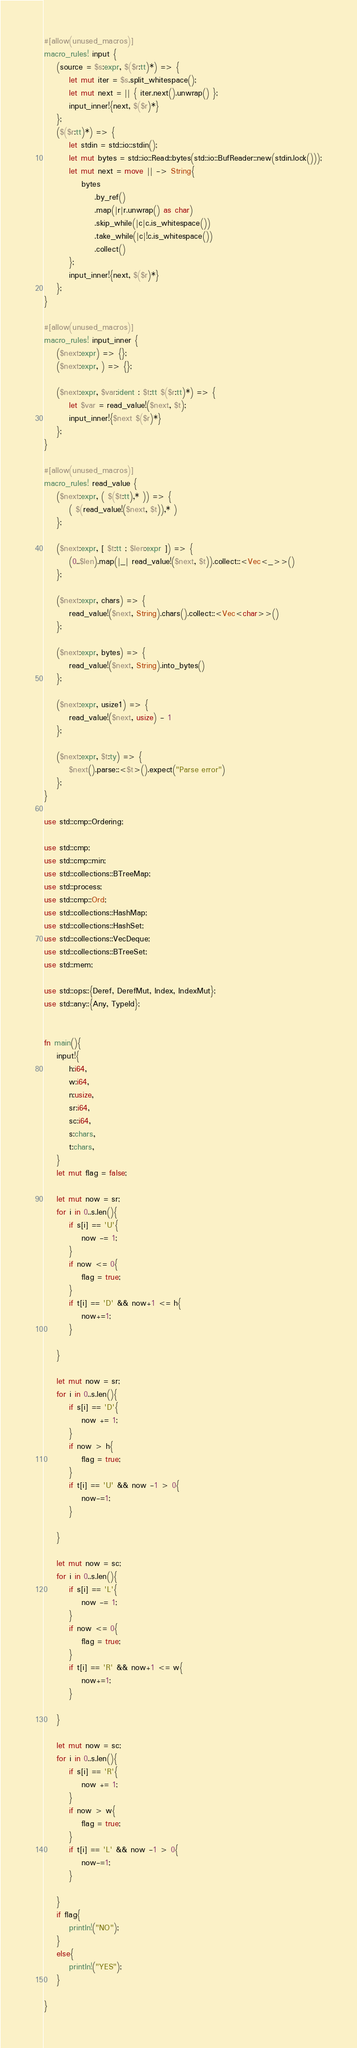<code> <loc_0><loc_0><loc_500><loc_500><_Rust_>#[allow(unused_macros)]
macro_rules! input {
    (source = $s:expr, $($r:tt)*) => {
        let mut iter = $s.split_whitespace();
        let mut next = || { iter.next().unwrap() };
        input_inner!{next, $($r)*}
    };
    ($($r:tt)*) => {
        let stdin = std::io::stdin();
        let mut bytes = std::io::Read::bytes(std::io::BufReader::new(stdin.lock()));
        let mut next = move || -> String{
            bytes
                .by_ref()
                .map(|r|r.unwrap() as char)
                .skip_while(|c|c.is_whitespace())
                .take_while(|c|!c.is_whitespace())
                .collect()
        };
        input_inner!{next, $($r)*}
    };
}
 
#[allow(unused_macros)]
macro_rules! input_inner {
    ($next:expr) => {};
    ($next:expr, ) => {};
 
    ($next:expr, $var:ident : $t:tt $($r:tt)*) => {
        let $var = read_value!($next, $t);
        input_inner!{$next $($r)*}
    };
}
 
#[allow(unused_macros)]
macro_rules! read_value {
    ($next:expr, ( $($t:tt),* )) => {
        ( $(read_value!($next, $t)),* )
    };
 
    ($next:expr, [ $t:tt ; $len:expr ]) => {
        (0..$len).map(|_| read_value!($next, $t)).collect::<Vec<_>>()
    };
 
    ($next:expr, chars) => {
        read_value!($next, String).chars().collect::<Vec<char>>()
    };
 
    ($next:expr, bytes) => {
        read_value!($next, String).into_bytes()
    };
 
    ($next:expr, usize1) => {
        read_value!($next, usize) - 1
    };
 
    ($next:expr, $t:ty) => {
        $next().parse::<$t>().expect("Parse error")
    };
}
 
use std::cmp::Ordering;
 
use std::cmp;
use std::cmp::min;
use std::collections::BTreeMap;
use std::process;
use std::cmp::Ord;
use std::collections::HashMap;
use std::collections::HashSet;
use std::collections::VecDeque;
use std::collections::BTreeSet;
use std::mem;
 
use std::ops::{Deref, DerefMut, Index, IndexMut};
use std::any::{Any, TypeId};


fn main(){
    input!{
        h:i64,
        w:i64,
        n:usize,
        sr:i64,
        sc:i64,
        s:chars,
        t:chars,
    }
    let mut flag = false;

    let mut now = sr;
    for i in 0..s.len(){
        if s[i] == 'U'{
            now -= 1;
        }
        if now <= 0{
            flag = true;
        }
        if t[i] == 'D' && now+1 <= h{
            now+=1;
        }
        
    }

    let mut now = sr;
    for i in 0..s.len(){
        if s[i] == 'D'{
            now += 1;
        }
        if now > h{
            flag = true;
        }
        if t[i] == 'U' && now -1 > 0{
            now-=1;
        }
        
    }

    let mut now = sc;
    for i in 0..s.len(){
        if s[i] == 'L'{
            now -= 1;
        }
        if now <= 0{
            flag = true;
        }
        if t[i] == 'R' && now+1 <= w{
            now+=1;
        }
        
    }

    let mut now = sc;
    for i in 0..s.len(){
        if s[i] == 'R'{
            now += 1;
        }
        if now > w{
            flag = true;
        }
        if t[i] == 'L' && now -1 > 0{
            now-=1;
        }
        
    }
    if flag{
        println!("NO");
    }
    else{
        println!("YES");
    }

}

</code> 